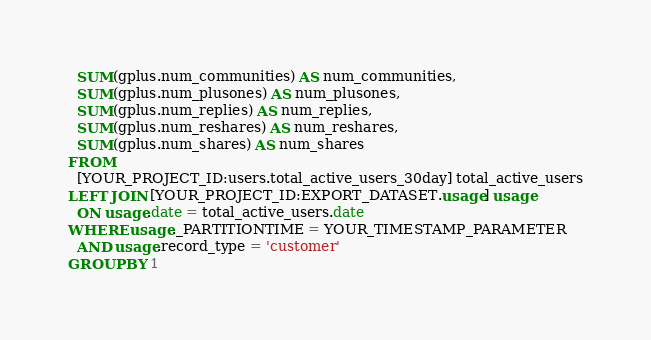Convert code to text. <code><loc_0><loc_0><loc_500><loc_500><_SQL_>  SUM(gplus.num_communities) AS num_communities,
  SUM(gplus.num_plusones) AS num_plusones,
  SUM(gplus.num_replies) AS num_replies,
  SUM(gplus.num_reshares) AS num_reshares,
  SUM(gplus.num_shares) AS num_shares
FROM
  [YOUR_PROJECT_ID:users.total_active_users_30day] total_active_users
LEFT JOIN [YOUR_PROJECT_ID:EXPORT_DATASET.usage] usage
  ON usage.date = total_active_users.date
WHERE usage._PARTITIONTIME = YOUR_TIMESTAMP_PARAMETER
  AND usage.record_type = 'customer'
GROUP BY 1</code> 